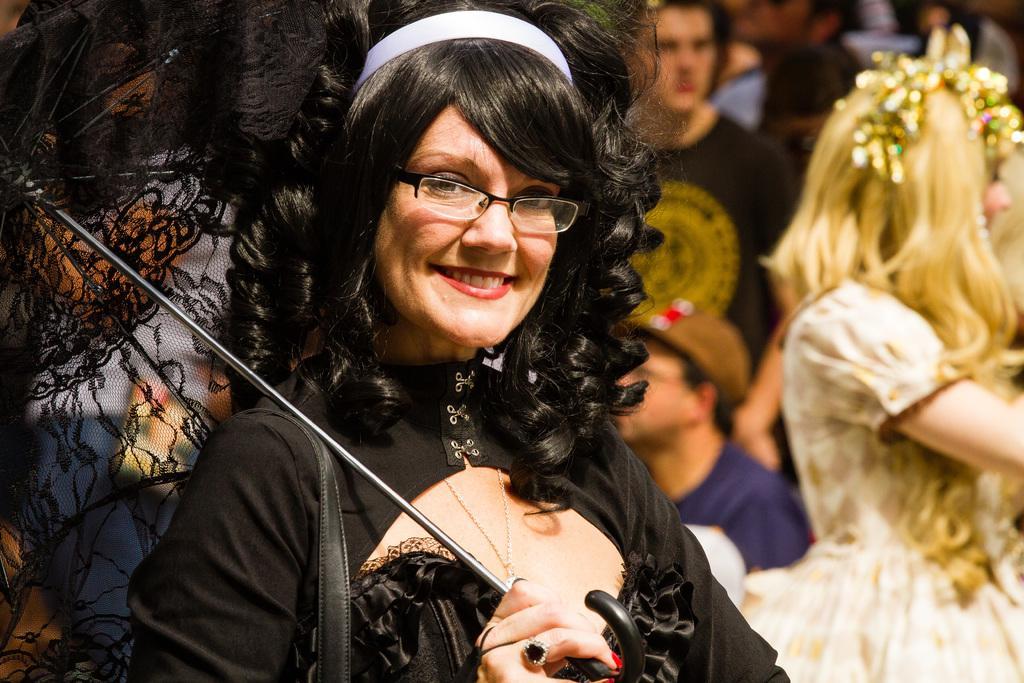Can you describe this image briefly? In this picture we can see people. This picture is mainly highlighted with a woman wearing a black dress and spectacles. She is holding an umbrella and smiling. 